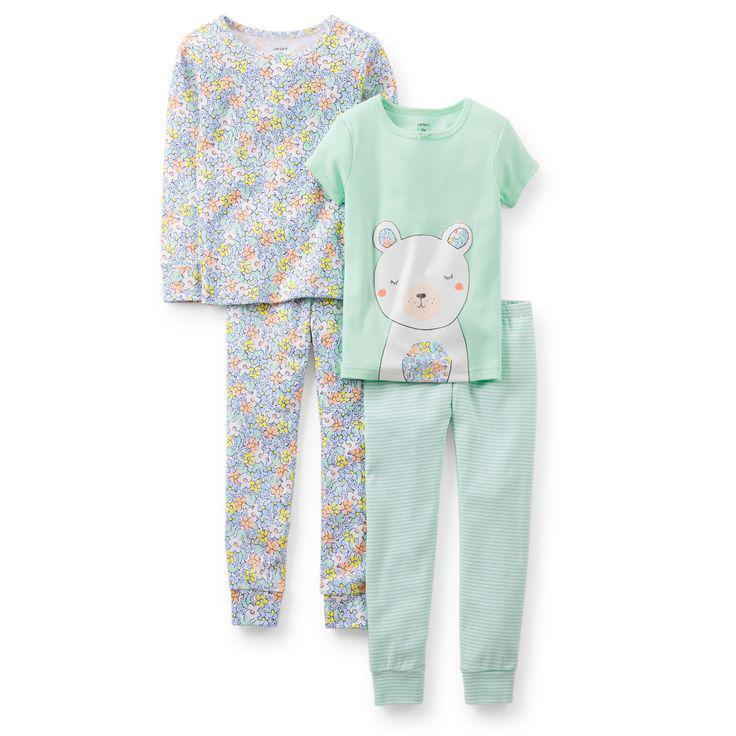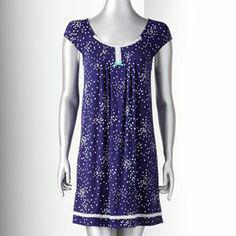The first image is the image on the left, the second image is the image on the right. Assess this claim about the two images: "Each image contains one sleepwear outfit consisting of a patterned top and matching pants, but one outfit has long sleeves while the other has short ruffled sleeves.". Correct or not? Answer yes or no. No. 